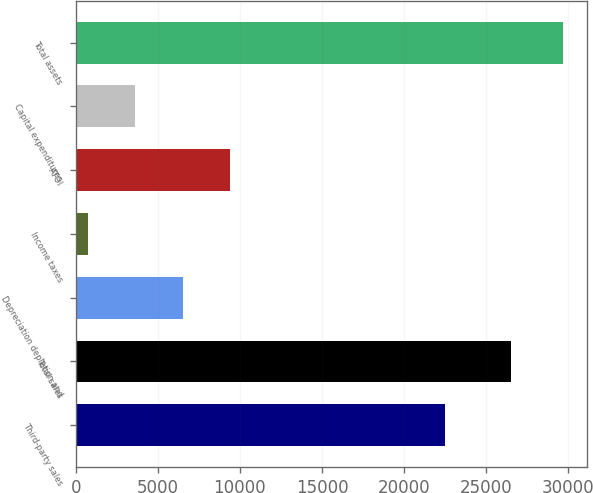Convert chart to OTSL. <chart><loc_0><loc_0><loc_500><loc_500><bar_chart><fcel>Third-party sales<fcel>Total sales<fcel>Depreciation depletion and<fcel>Income taxes<fcel>ATOI<fcel>Capital expenditures<fcel>Total assets<nl><fcel>22508<fcel>26490<fcel>6514<fcel>726<fcel>9408<fcel>3620<fcel>29666<nl></chart> 